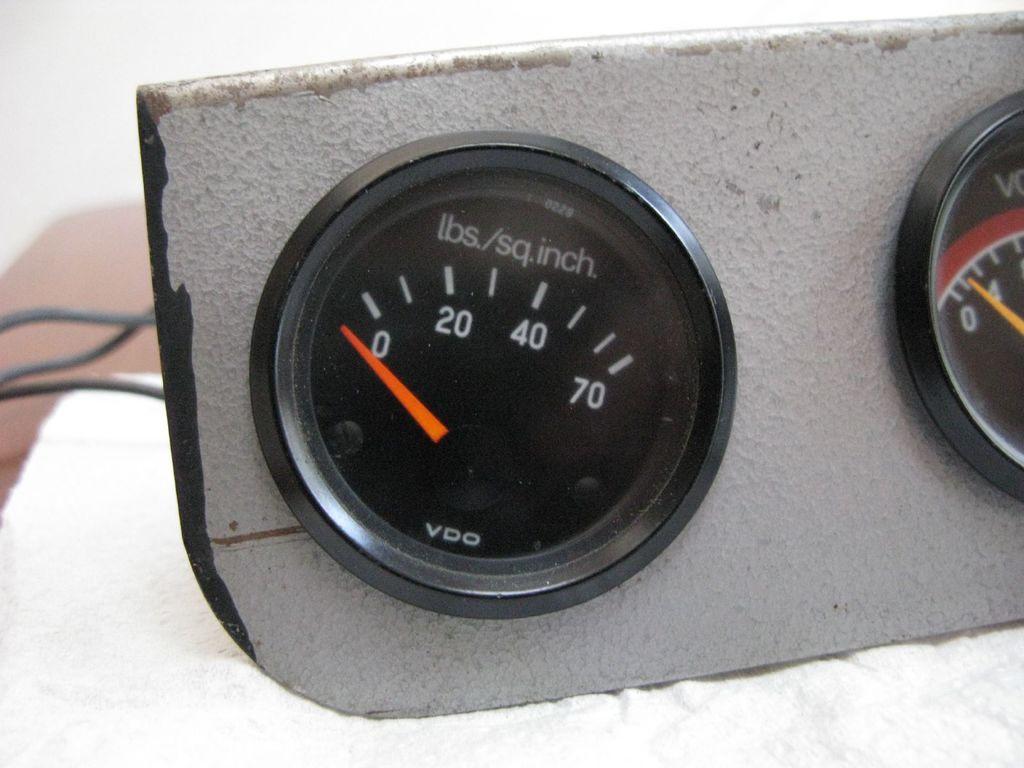In one or two sentences, can you explain what this image depicts? In this picture we can see two gauges, on the left side there are three wires, we can see a blurry background. 